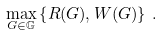Convert formula to latex. <formula><loc_0><loc_0><loc_500><loc_500>\max _ { G \in \mathbb { G } } \left \{ R ( G ) , W ( G ) \right \} \, .</formula> 